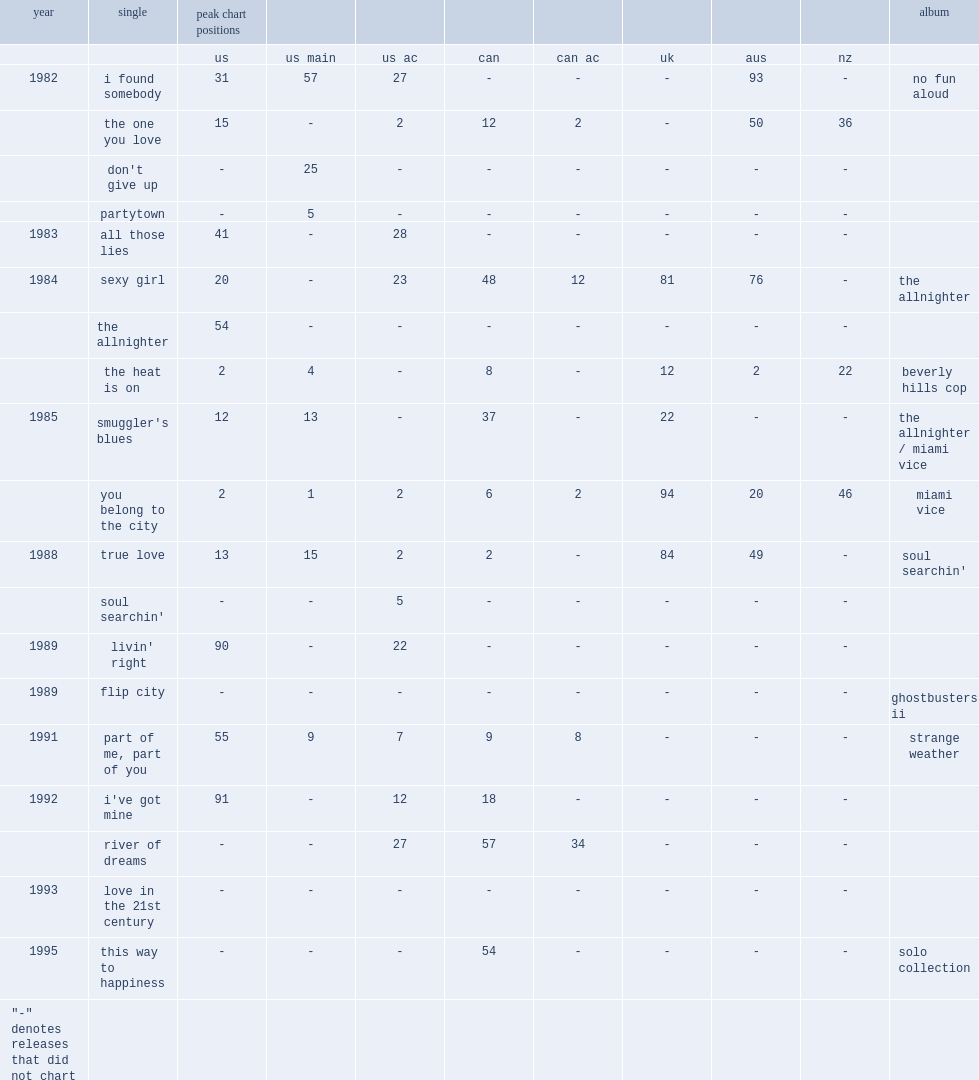When did "the one you love" release? 1982.0. 